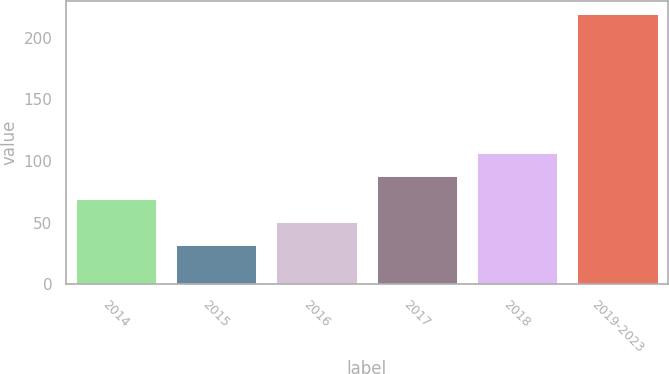Convert chart to OTSL. <chart><loc_0><loc_0><loc_500><loc_500><bar_chart><fcel>2014<fcel>2015<fcel>2016<fcel>2017<fcel>2018<fcel>2019-2023<nl><fcel>69.4<fcel>32<fcel>50.7<fcel>88.1<fcel>106.8<fcel>219<nl></chart> 